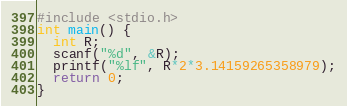<code> <loc_0><loc_0><loc_500><loc_500><_C_>#include <stdio.h>
int main() {
  int R;
  scanf("%d", &R);
  printf("%lf", R*2*3.14159265358979);
  return 0;
}
</code> 